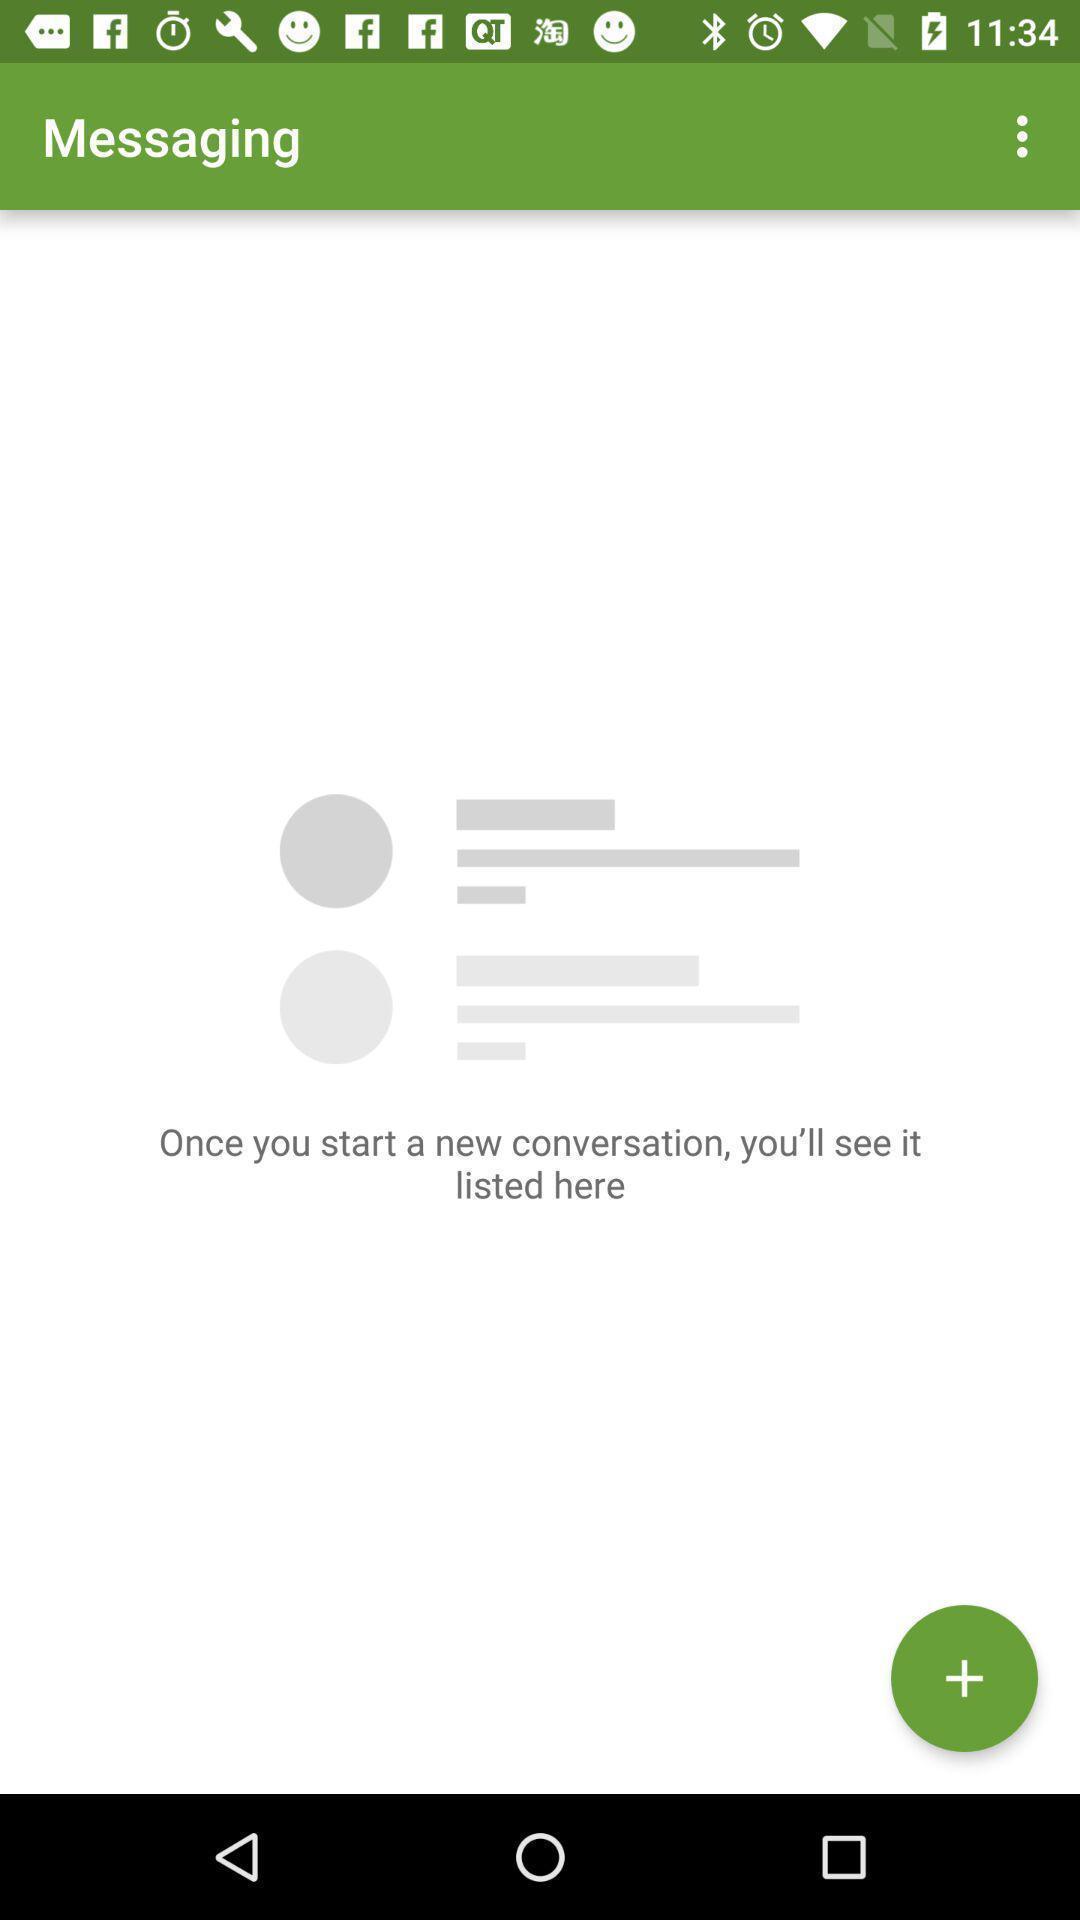What is the overall content of this screenshot? Page to start a new conversation. 